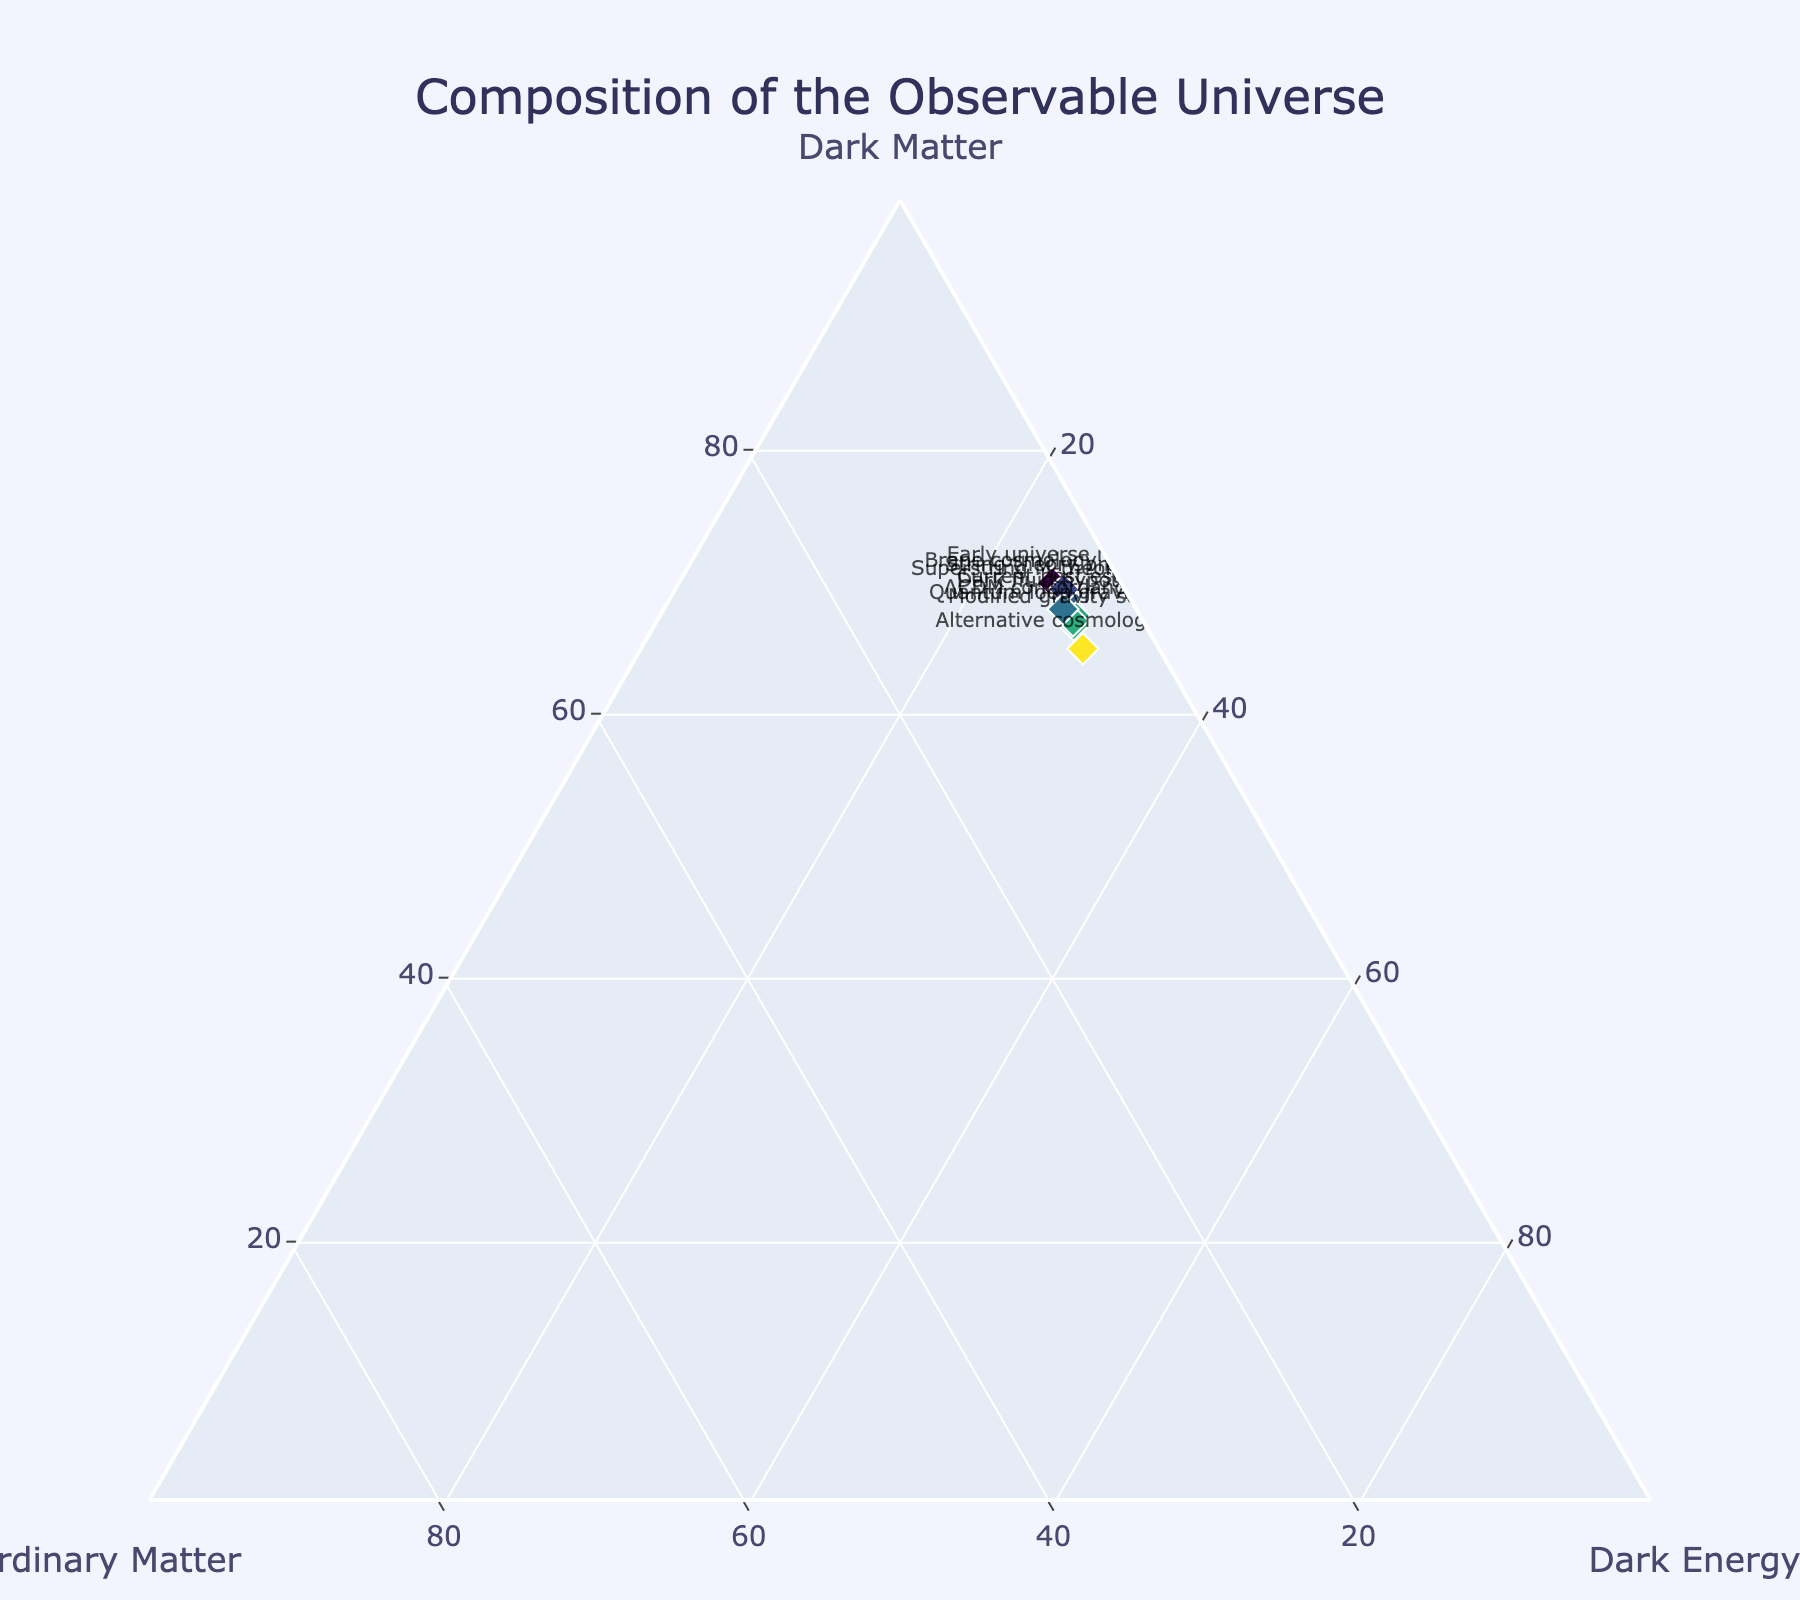What is the title of the figure? The title is displayed at the top center of the figure in a larger font size compared to the other text. It commonly summarizes the content of the plot.
Answer: Composition of the Observable Universe How many data points are shown on the plot? Each data point is represented by a diamond-shaped marker with text labels pertaining to different cosmological models. By counting the markers, we find there are 10 data points.
Answer: 10 Which model predicts the highest proportion of dark matter? The model with the highest percentage in the axis labeled "Dark Matter" is the Early universe model with 70.0%.
Answer: Early universe model What is the average percentage of ordinary matter across all models? Sum the values of ordinary matter for all models and divide by the number of models: (4.9 + 5.0 + 5.5 + 4.8 + 4.6 + 5.2 + 4.7 + 5.1 + 4.5 + 5.3) / 10 = 49.6 / 10 = 4.96%.
Answer: 4.96% Which cosmological theory has the lowest percentage of dark energy according to the plot? Check the "Dark Energy" axis for the smallest value, which is 25.0% under the Early universe model.
Answer: Early universe model What is the difference in dark matter percentage between the ΛCDM concordance model and the Modified gravity scenario? λCDM has 67.5% dark matter and Modified gravity scenario has 66.8%. The difference is 67.5% - 66.8% = 0.7%.
Answer: 0.7% If you average the dark energy content from the first three models, what is the result? Add the percentages of dark energy from the Current best estimate, Early universe model, and Alternative cosmology theory: 26.8 + 25.0 + 29.5 = 81.3. Then divide by 3: 81.3 / 3 = 27.1%.
Answer: 27.1% Which model predicts a higher proportion of ordinary matter: String theory prediction or Quantum loop gravity model? String theory prediction indicates 4.6% ordinary matter, while Quantum loop gravity model indicates 5.1%. Thus, Quantum loop gravity model predicts more ordinary matter.
Answer: Quantum loop gravity model How does the Brane cosmology prediction’s dark energy value compare with the Dark fluid hypothesis’s value? Brane cosmology predicts 26.0% dark energy whereas Dark fluid hypothesis predicts 26.7%, so Dark fluid hypothesis has a higher dark energy percentage.
Answer: Dark fluid hypothesis Which models have a dark matter percentage close to the current best estimate? The current best estimate for dark matter is 68.3%. Models close to this value include:
- Superstring M-theory estimate: 68.9%
- Dark fluid hypothesis: 68.0%
- String theory prediction: 69.2%
Answer: Superstring M-theory estimate, Dark fluid hypothesis, String theory prediction 